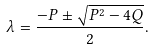<formula> <loc_0><loc_0><loc_500><loc_500>\lambda = \frac { - P \pm \sqrt { P ^ { 2 } - 4 Q } } { 2 } .</formula> 